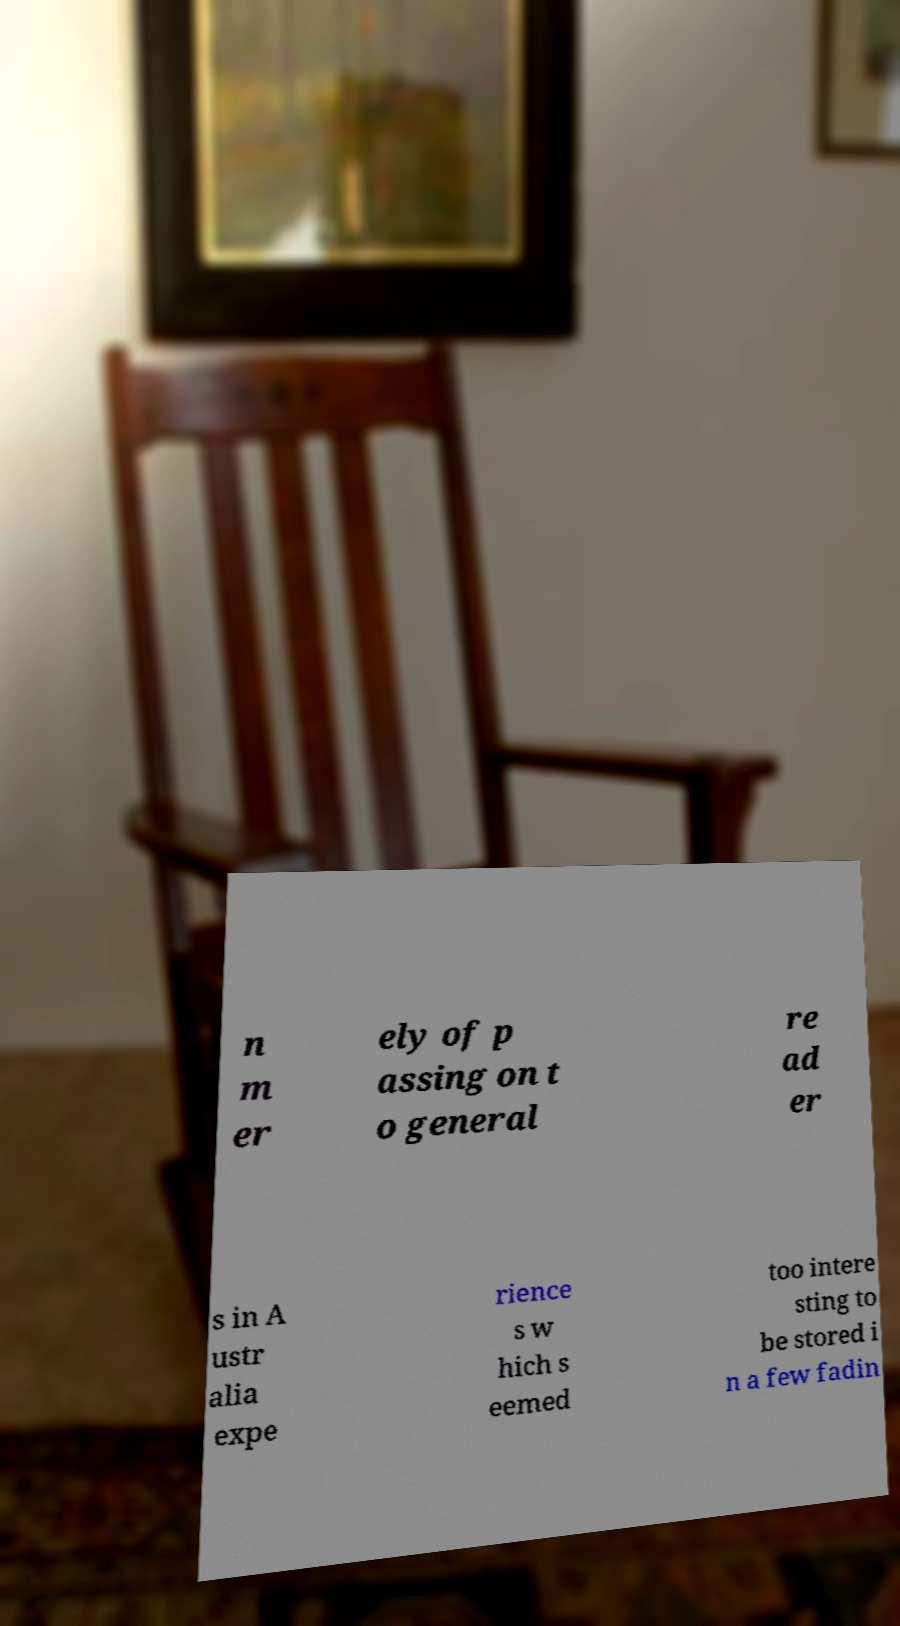I need the written content from this picture converted into text. Can you do that? n m er ely of p assing on t o general re ad er s in A ustr alia expe rience s w hich s eemed too intere sting to be stored i n a few fadin 